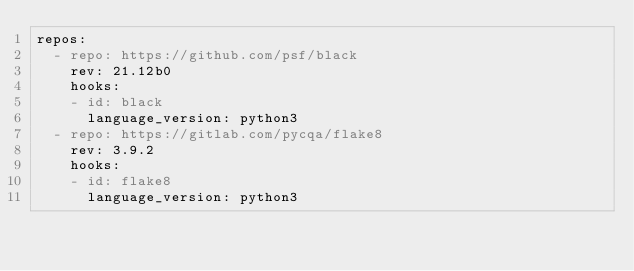<code> <loc_0><loc_0><loc_500><loc_500><_YAML_>repos:
  - repo: https://github.com/psf/black
    rev: 21.12b0
    hooks:
    - id: black
      language_version: python3
  - repo: https://gitlab.com/pycqa/flake8
    rev: 3.9.2
    hooks:
    - id: flake8
      language_version: python3
</code> 